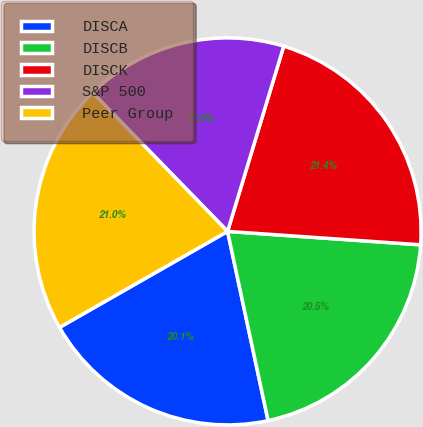<chart> <loc_0><loc_0><loc_500><loc_500><pie_chart><fcel>DISCA<fcel>DISCB<fcel>DISCK<fcel>S&P 500<fcel>Peer Group<nl><fcel>20.1%<fcel>20.54%<fcel>21.42%<fcel>16.97%<fcel>20.98%<nl></chart> 